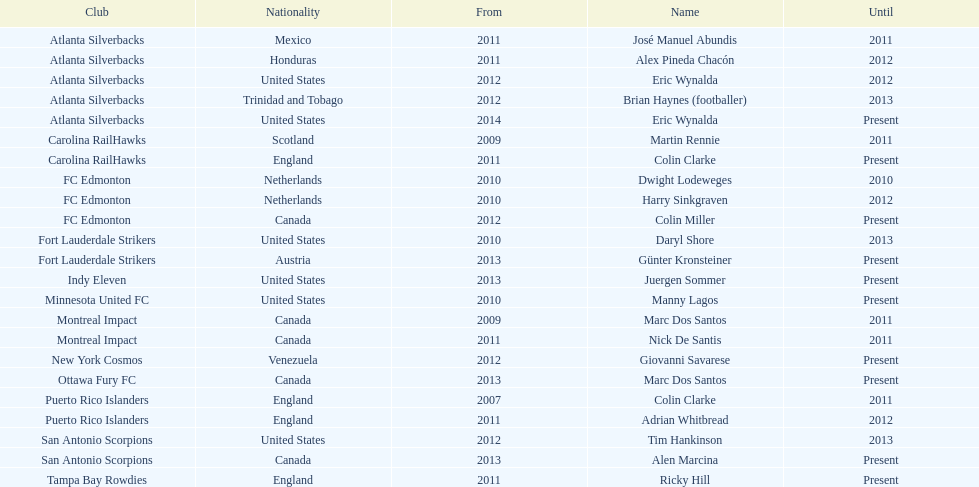Marc dos santos started as coach the same year as what other coach? Martin Rennie. 